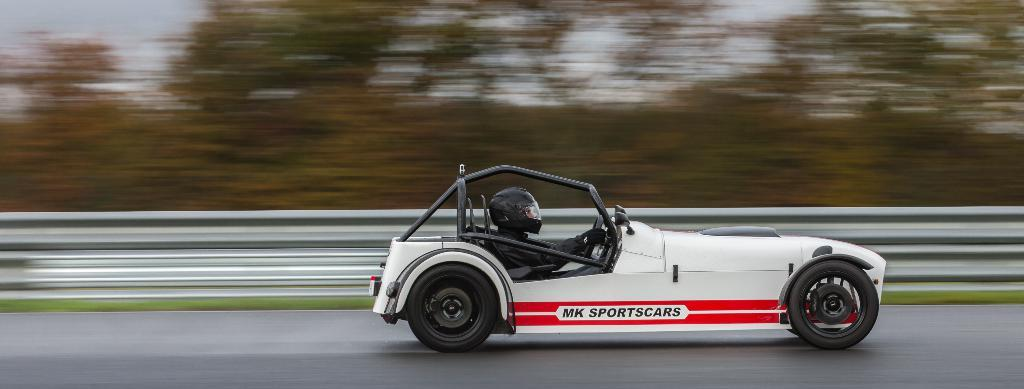What is the person in the image doing? The person is sitting in a car and riding it on the road. What safety precaution is the person taking? The person is wearing a helmet. What can be seen in the background of the image? The background of the image is blurry, but the sky and trees are visible. What design is featured on the person's hands in the image? There is no information about the person's hands or any design on them in the image. 